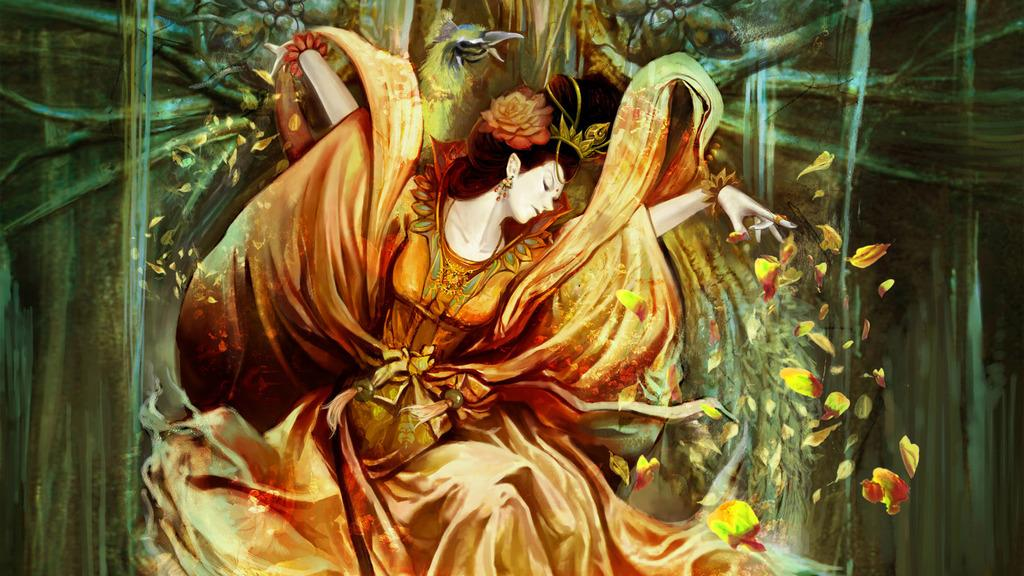What is depicted in the image? There is a drawing of a woman in the image. What is the woman wearing in the drawing? The woman is wearing an orange dress in the drawing. What else can be seen in the image besides the drawing of the woman? There are dry tree branches visible in the image. How many wrens can be seen perched on the woman's leg in the image? There are no wrens or legs visible in the image; it features a drawing of a woman wearing an orange dress and dry tree branches. 